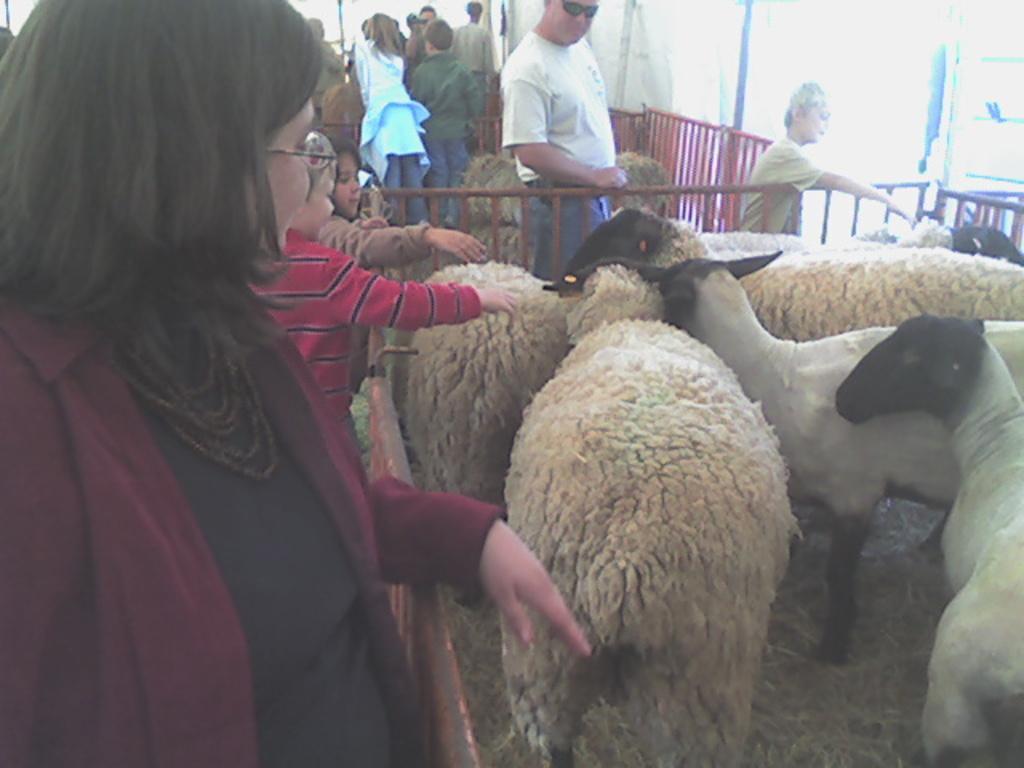Describe this image in one or two sentences. There are many sheep. Around them there are railings. Also there are many people standing. On the ground there are dried leaves. 